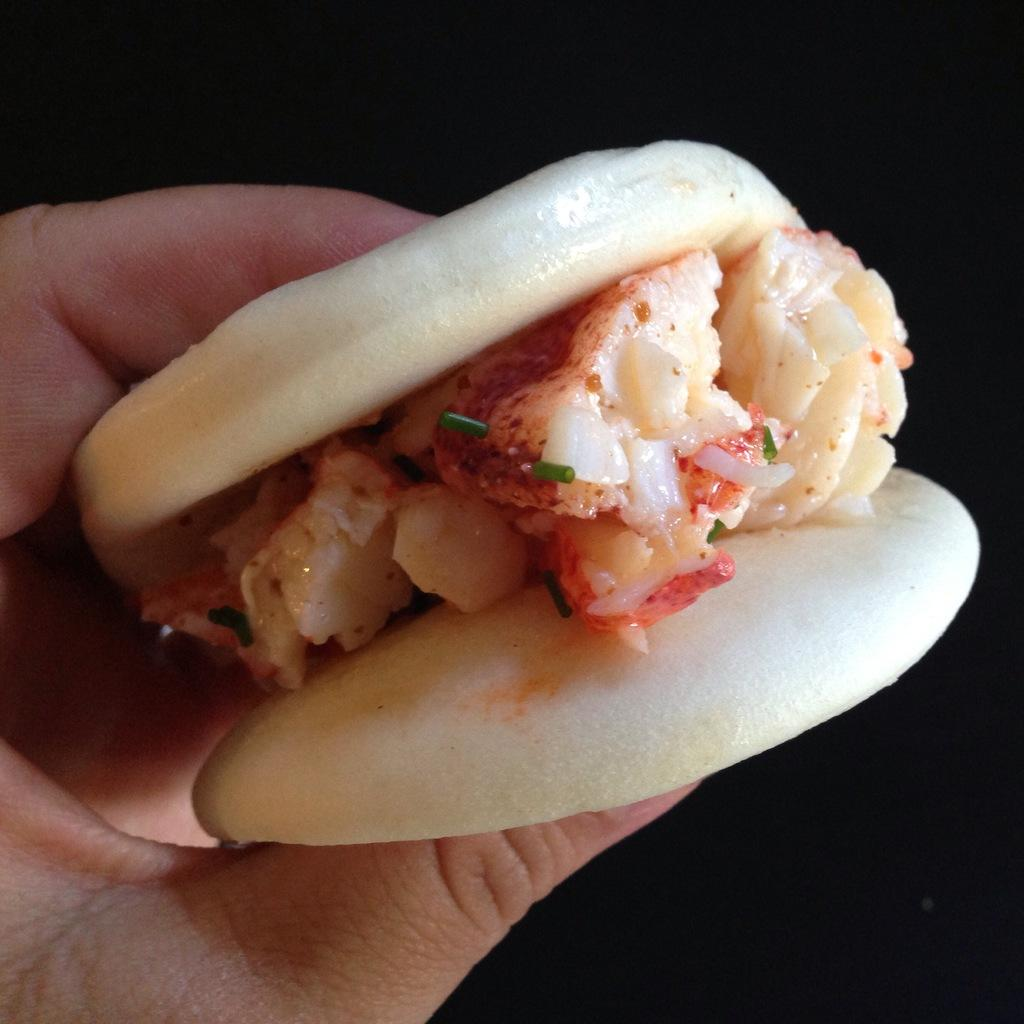What is the person's hand holding in the image? The person's hand is holding a burger in the image. What can be observed about the background of the image? The background of the image is dark. How does the person's hand communicate with the parent in the image? There is no parent present in the image, and the person's hand is not communicating with anyone. What type of animal with a tail can be seen in the image? There are no animals with tails present in the image. 